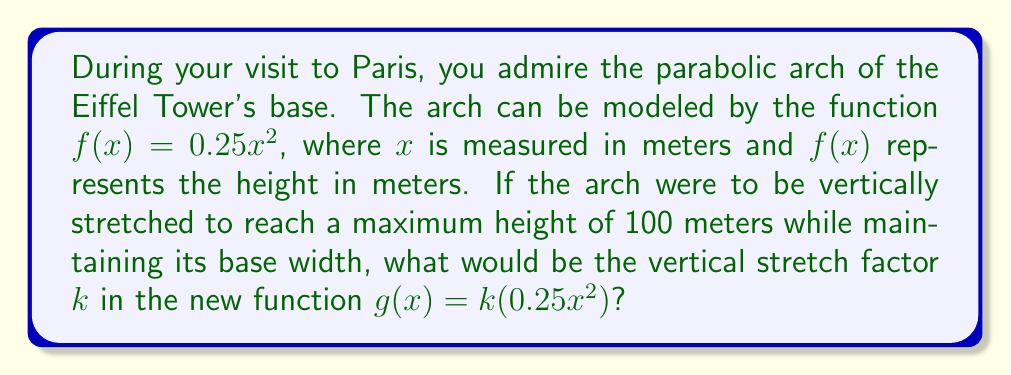Can you solve this math problem? Let's approach this step-by-step:

1) The original function is $f(x)=0.25x^2$.

2) We need to find $k$ for the new function $g(x)=k(0.25x^2)$.

3) To find the maximum height of the original arch, we need to know its width. The Eiffel Tower's base arch spans approximately 80 meters. So, $x$ ranges from -40 to 40.

4) The maximum height occurs at $x=40$ (or $x=-40$):
   $f(40) = 0.25(40)^2 = 0.25(1600) = 400$ meters

5) We want the new maximum height to be 100 meters. This means:
   $g(40) = k(0.25(40)^2) = 100$

6) Substituting the values:
   $k(400) = 100$

7) Solving for $k$:
   $k = \frac{100}{400} = \frac{1}{4} = 0.25$

Therefore, the vertical stretch factor $k$ is 0.25.
Answer: $k = 0.25$ 